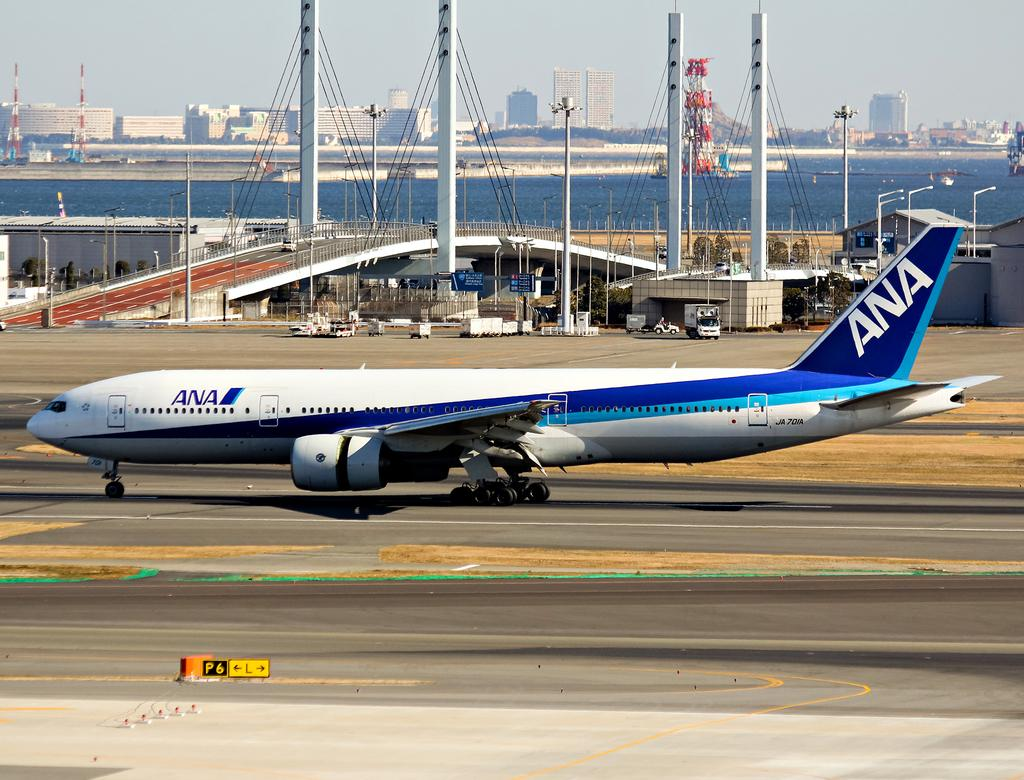<image>
Relay a brief, clear account of the picture shown. An ANA airplane is on the runway outside. 